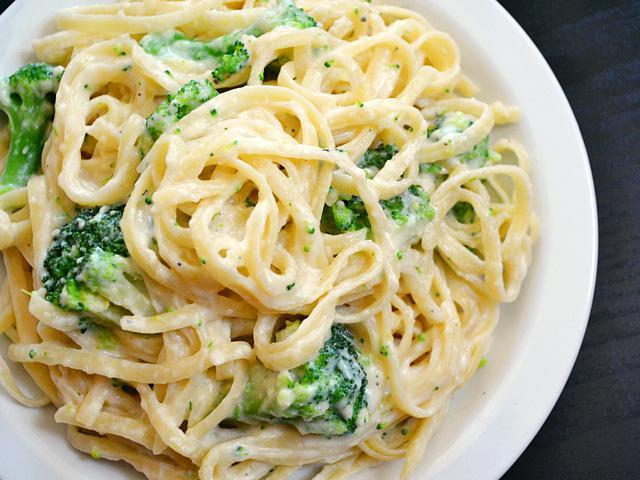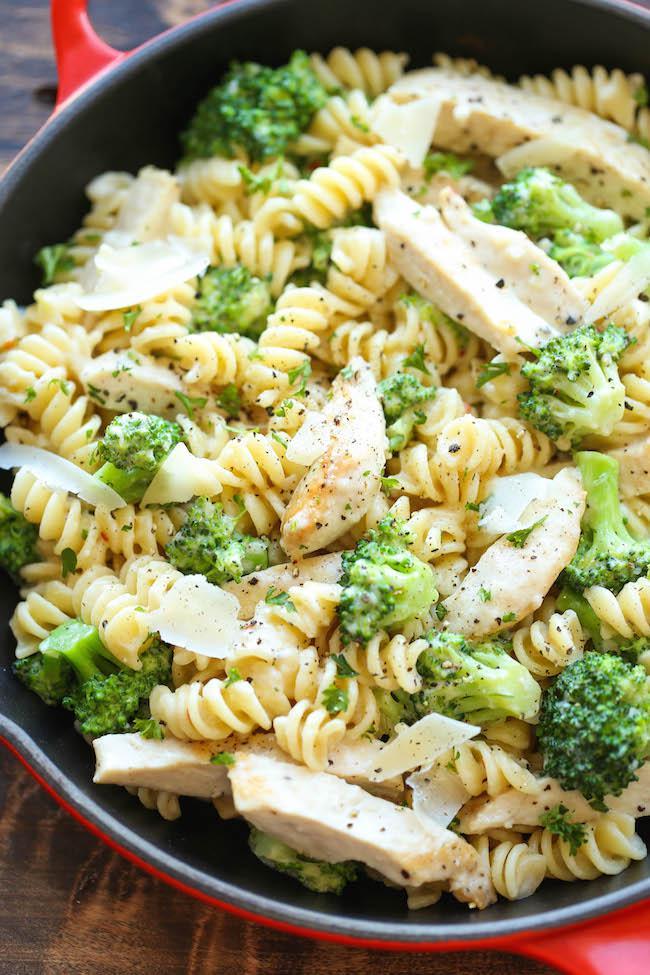The first image is the image on the left, the second image is the image on the right. Analyze the images presented: Is the assertion "At least one of the dishes doesn't have penne pasta." valid? Answer yes or no. Yes. 